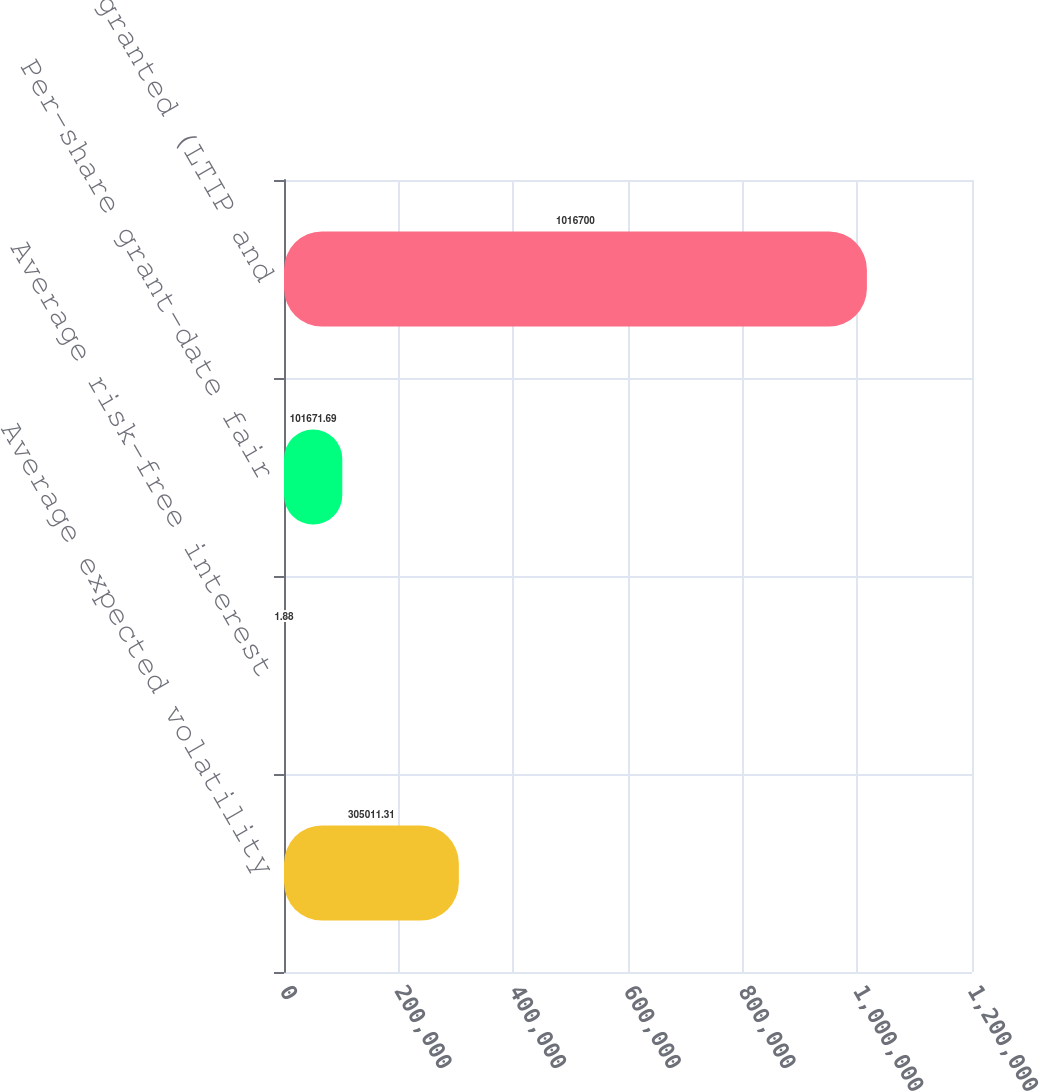Convert chart. <chart><loc_0><loc_0><loc_500><loc_500><bar_chart><fcel>Average expected volatility<fcel>Average risk-free interest<fcel>Per-share grant-date fair<fcel>Options granted (LTIP and<nl><fcel>305011<fcel>1.88<fcel>101672<fcel>1.0167e+06<nl></chart> 